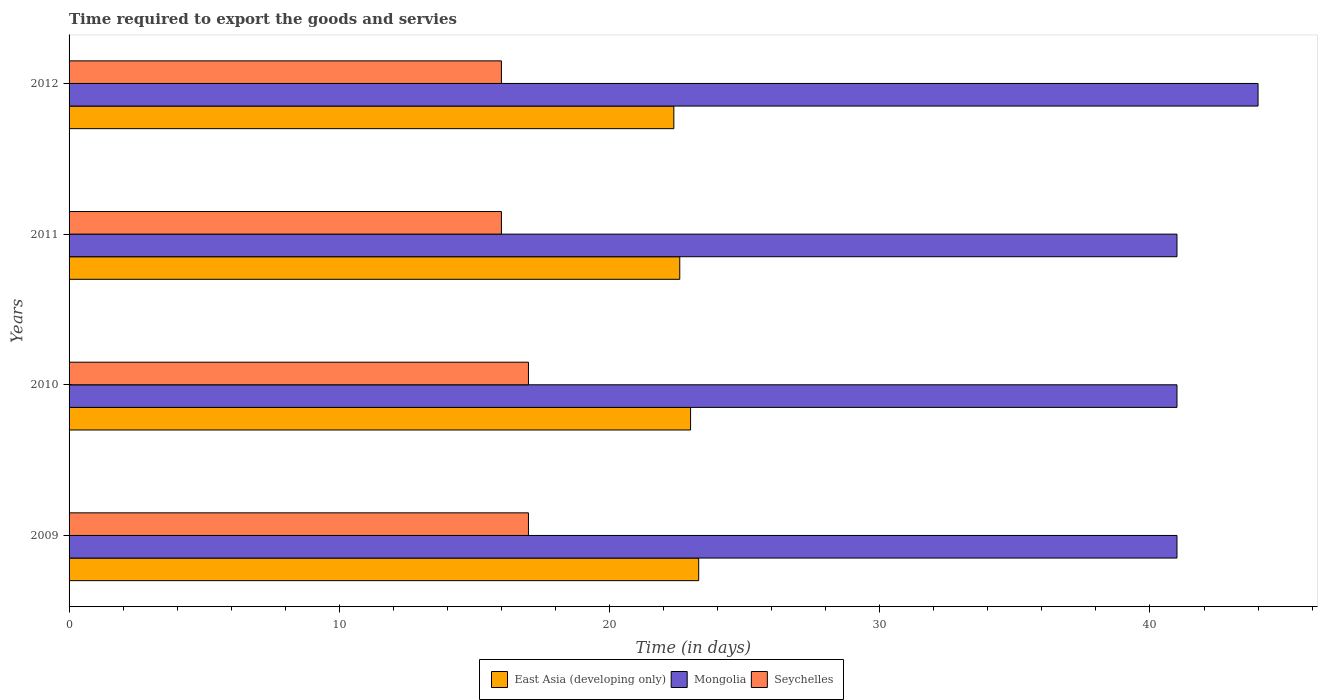How many different coloured bars are there?
Keep it short and to the point. 3. How many groups of bars are there?
Make the answer very short. 4. How many bars are there on the 4th tick from the top?
Ensure brevity in your answer.  3. How many bars are there on the 3rd tick from the bottom?
Make the answer very short. 3. What is the label of the 2nd group of bars from the top?
Offer a very short reply. 2011. What is the number of days required to export the goods and services in Mongolia in 2011?
Offer a terse response. 41. Across all years, what is the maximum number of days required to export the goods and services in Mongolia?
Make the answer very short. 44. Across all years, what is the minimum number of days required to export the goods and services in East Asia (developing only)?
Offer a very short reply. 22.38. What is the total number of days required to export the goods and services in East Asia (developing only) in the graph?
Ensure brevity in your answer.  91.28. What is the difference between the number of days required to export the goods and services in Mongolia in 2010 and that in 2012?
Your response must be concise. -3. What is the difference between the number of days required to export the goods and services in East Asia (developing only) in 2010 and the number of days required to export the goods and services in Mongolia in 2011?
Offer a very short reply. -18. What is the average number of days required to export the goods and services in East Asia (developing only) per year?
Provide a succinct answer. 22.82. In the year 2009, what is the difference between the number of days required to export the goods and services in East Asia (developing only) and number of days required to export the goods and services in Mongolia?
Provide a succinct answer. -17.7. In how many years, is the number of days required to export the goods and services in Seychelles greater than 2 days?
Your answer should be compact. 4. What is the ratio of the number of days required to export the goods and services in Mongolia in 2011 to that in 2012?
Your answer should be very brief. 0.93. Is the number of days required to export the goods and services in Seychelles in 2009 less than that in 2011?
Ensure brevity in your answer.  No. What is the difference between the highest and the second highest number of days required to export the goods and services in East Asia (developing only)?
Give a very brief answer. 0.3. What is the difference between the highest and the lowest number of days required to export the goods and services in East Asia (developing only)?
Provide a short and direct response. 0.92. What does the 3rd bar from the top in 2010 represents?
Offer a very short reply. East Asia (developing only). What does the 2nd bar from the bottom in 2009 represents?
Your answer should be compact. Mongolia. How many years are there in the graph?
Your answer should be very brief. 4. Are the values on the major ticks of X-axis written in scientific E-notation?
Your response must be concise. No. Does the graph contain any zero values?
Offer a very short reply. No. How many legend labels are there?
Keep it short and to the point. 3. How are the legend labels stacked?
Your response must be concise. Horizontal. What is the title of the graph?
Give a very brief answer. Time required to export the goods and servies. What is the label or title of the X-axis?
Provide a short and direct response. Time (in days). What is the Time (in days) in East Asia (developing only) in 2009?
Keep it short and to the point. 23.3. What is the Time (in days) in Mongolia in 2009?
Your response must be concise. 41. What is the Time (in days) of Seychelles in 2009?
Your answer should be very brief. 17. What is the Time (in days) of Mongolia in 2010?
Your answer should be very brief. 41. What is the Time (in days) in East Asia (developing only) in 2011?
Your answer should be very brief. 22.6. What is the Time (in days) in East Asia (developing only) in 2012?
Your response must be concise. 22.38. What is the Time (in days) in Mongolia in 2012?
Your answer should be very brief. 44. What is the Time (in days) of Seychelles in 2012?
Your response must be concise. 16. Across all years, what is the maximum Time (in days) in East Asia (developing only)?
Offer a very short reply. 23.3. Across all years, what is the minimum Time (in days) of East Asia (developing only)?
Provide a succinct answer. 22.38. Across all years, what is the minimum Time (in days) in Seychelles?
Your answer should be compact. 16. What is the total Time (in days) in East Asia (developing only) in the graph?
Make the answer very short. 91.28. What is the total Time (in days) of Mongolia in the graph?
Provide a short and direct response. 167. What is the total Time (in days) of Seychelles in the graph?
Keep it short and to the point. 66. What is the difference between the Time (in days) of East Asia (developing only) in 2009 and that in 2010?
Provide a short and direct response. 0.3. What is the difference between the Time (in days) of Mongolia in 2009 and that in 2010?
Provide a short and direct response. 0. What is the difference between the Time (in days) of Seychelles in 2009 and that in 2010?
Offer a terse response. 0. What is the difference between the Time (in days) in Seychelles in 2009 and that in 2011?
Your answer should be compact. 1. What is the difference between the Time (in days) in East Asia (developing only) in 2009 and that in 2012?
Keep it short and to the point. 0.92. What is the difference between the Time (in days) of Mongolia in 2009 and that in 2012?
Your answer should be very brief. -3. What is the difference between the Time (in days) of Seychelles in 2009 and that in 2012?
Give a very brief answer. 1. What is the difference between the Time (in days) in Mongolia in 2010 and that in 2011?
Your answer should be compact. 0. What is the difference between the Time (in days) in East Asia (developing only) in 2010 and that in 2012?
Keep it short and to the point. 0.62. What is the difference between the Time (in days) of Mongolia in 2010 and that in 2012?
Offer a terse response. -3. What is the difference between the Time (in days) of Seychelles in 2010 and that in 2012?
Your answer should be compact. 1. What is the difference between the Time (in days) in East Asia (developing only) in 2011 and that in 2012?
Your answer should be compact. 0.22. What is the difference between the Time (in days) in Mongolia in 2011 and that in 2012?
Provide a short and direct response. -3. What is the difference between the Time (in days) of Seychelles in 2011 and that in 2012?
Your answer should be compact. 0. What is the difference between the Time (in days) in East Asia (developing only) in 2009 and the Time (in days) in Mongolia in 2010?
Your answer should be very brief. -17.7. What is the difference between the Time (in days) in East Asia (developing only) in 2009 and the Time (in days) in Mongolia in 2011?
Your answer should be very brief. -17.7. What is the difference between the Time (in days) in Mongolia in 2009 and the Time (in days) in Seychelles in 2011?
Give a very brief answer. 25. What is the difference between the Time (in days) of East Asia (developing only) in 2009 and the Time (in days) of Mongolia in 2012?
Your answer should be compact. -20.7. What is the difference between the Time (in days) of Mongolia in 2009 and the Time (in days) of Seychelles in 2012?
Offer a terse response. 25. What is the difference between the Time (in days) of East Asia (developing only) in 2010 and the Time (in days) of Mongolia in 2011?
Your answer should be compact. -18. What is the difference between the Time (in days) of East Asia (developing only) in 2010 and the Time (in days) of Mongolia in 2012?
Your answer should be compact. -21. What is the difference between the Time (in days) of Mongolia in 2010 and the Time (in days) of Seychelles in 2012?
Provide a succinct answer. 25. What is the difference between the Time (in days) of East Asia (developing only) in 2011 and the Time (in days) of Mongolia in 2012?
Your answer should be compact. -21.4. What is the difference between the Time (in days) of East Asia (developing only) in 2011 and the Time (in days) of Seychelles in 2012?
Offer a very short reply. 6.6. What is the difference between the Time (in days) in Mongolia in 2011 and the Time (in days) in Seychelles in 2012?
Make the answer very short. 25. What is the average Time (in days) of East Asia (developing only) per year?
Offer a terse response. 22.82. What is the average Time (in days) of Mongolia per year?
Offer a terse response. 41.75. What is the average Time (in days) in Seychelles per year?
Provide a succinct answer. 16.5. In the year 2009, what is the difference between the Time (in days) of East Asia (developing only) and Time (in days) of Mongolia?
Offer a terse response. -17.7. In the year 2009, what is the difference between the Time (in days) of East Asia (developing only) and Time (in days) of Seychelles?
Your answer should be compact. 6.3. In the year 2010, what is the difference between the Time (in days) in East Asia (developing only) and Time (in days) in Mongolia?
Offer a very short reply. -18. In the year 2011, what is the difference between the Time (in days) of East Asia (developing only) and Time (in days) of Mongolia?
Offer a terse response. -18.4. In the year 2011, what is the difference between the Time (in days) of East Asia (developing only) and Time (in days) of Seychelles?
Your answer should be compact. 6.6. In the year 2011, what is the difference between the Time (in days) of Mongolia and Time (in days) of Seychelles?
Provide a short and direct response. 25. In the year 2012, what is the difference between the Time (in days) in East Asia (developing only) and Time (in days) in Mongolia?
Give a very brief answer. -21.62. In the year 2012, what is the difference between the Time (in days) in East Asia (developing only) and Time (in days) in Seychelles?
Your answer should be very brief. 6.38. What is the ratio of the Time (in days) of East Asia (developing only) in 2009 to that in 2010?
Give a very brief answer. 1.01. What is the ratio of the Time (in days) of Seychelles in 2009 to that in 2010?
Provide a succinct answer. 1. What is the ratio of the Time (in days) in East Asia (developing only) in 2009 to that in 2011?
Your response must be concise. 1.03. What is the ratio of the Time (in days) in Mongolia in 2009 to that in 2011?
Provide a succinct answer. 1. What is the ratio of the Time (in days) in East Asia (developing only) in 2009 to that in 2012?
Give a very brief answer. 1.04. What is the ratio of the Time (in days) of Mongolia in 2009 to that in 2012?
Give a very brief answer. 0.93. What is the ratio of the Time (in days) in Seychelles in 2009 to that in 2012?
Offer a terse response. 1.06. What is the ratio of the Time (in days) in East Asia (developing only) in 2010 to that in 2011?
Offer a terse response. 1.02. What is the ratio of the Time (in days) in Mongolia in 2010 to that in 2011?
Give a very brief answer. 1. What is the ratio of the Time (in days) of Seychelles in 2010 to that in 2011?
Keep it short and to the point. 1.06. What is the ratio of the Time (in days) of East Asia (developing only) in 2010 to that in 2012?
Provide a succinct answer. 1.03. What is the ratio of the Time (in days) in Mongolia in 2010 to that in 2012?
Give a very brief answer. 0.93. What is the ratio of the Time (in days) of East Asia (developing only) in 2011 to that in 2012?
Offer a very short reply. 1.01. What is the ratio of the Time (in days) in Mongolia in 2011 to that in 2012?
Offer a terse response. 0.93. What is the difference between the highest and the second highest Time (in days) in Seychelles?
Your response must be concise. 0. What is the difference between the highest and the lowest Time (in days) in East Asia (developing only)?
Make the answer very short. 0.92. 